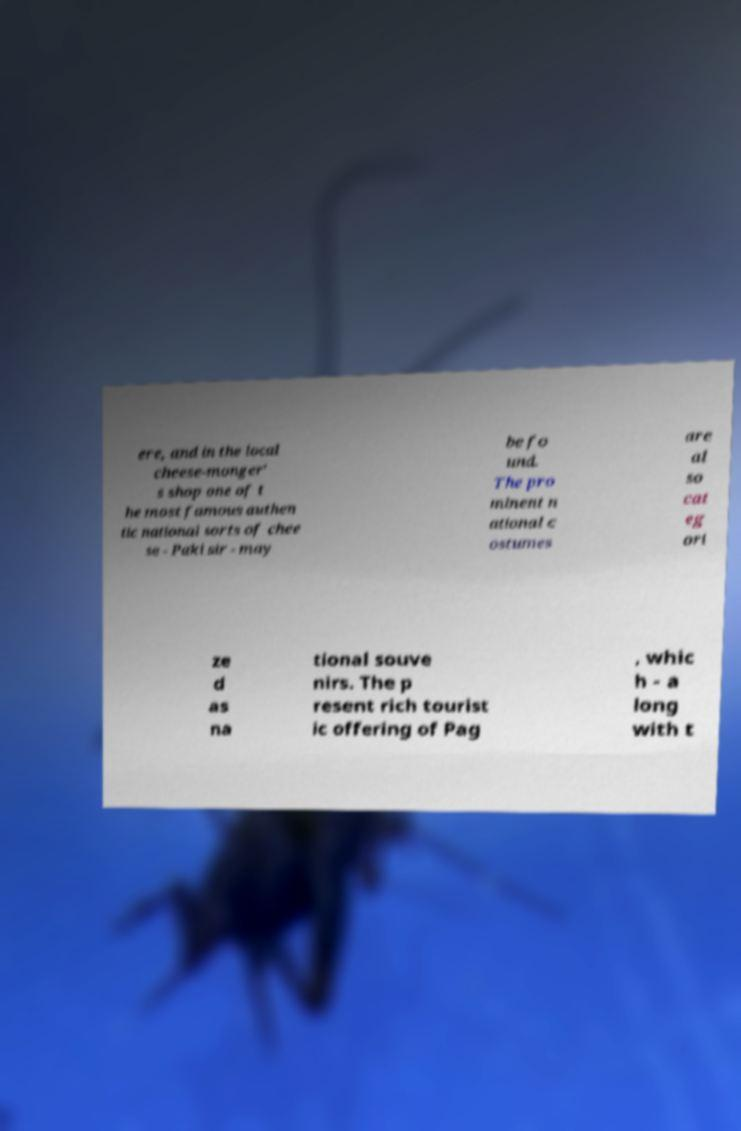For documentation purposes, I need the text within this image transcribed. Could you provide that? ere, and in the local cheese-monger' s shop one of t he most famous authen tic national sorts of chee se - Paki sir - may be fo und. The pro minent n ational c ostumes are al so cat eg ori ze d as na tional souve nirs. The p resent rich tourist ic offering of Pag , whic h - a long with t 